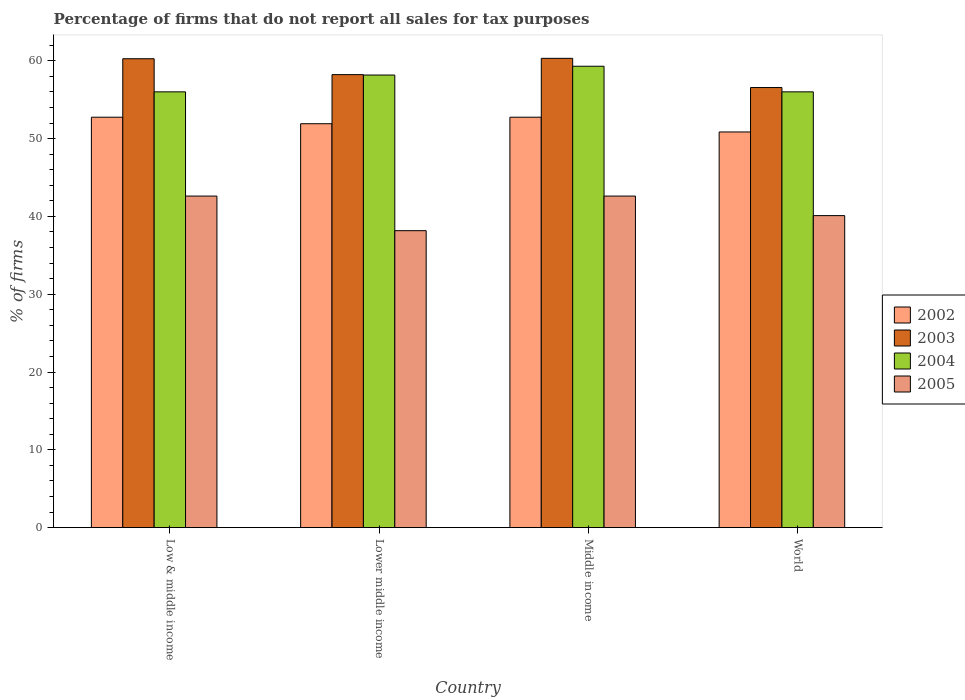How many different coloured bars are there?
Your response must be concise. 4. Are the number of bars per tick equal to the number of legend labels?
Provide a succinct answer. Yes. How many bars are there on the 4th tick from the left?
Your answer should be compact. 4. How many bars are there on the 4th tick from the right?
Offer a terse response. 4. What is the percentage of firms that do not report all sales for tax purposes in 2002 in Lower middle income?
Give a very brief answer. 51.91. Across all countries, what is the maximum percentage of firms that do not report all sales for tax purposes in 2004?
Keep it short and to the point. 59.3. Across all countries, what is the minimum percentage of firms that do not report all sales for tax purposes in 2002?
Offer a very short reply. 50.85. In which country was the percentage of firms that do not report all sales for tax purposes in 2004 maximum?
Your answer should be very brief. Middle income. What is the total percentage of firms that do not report all sales for tax purposes in 2004 in the graph?
Make the answer very short. 229.47. What is the difference between the percentage of firms that do not report all sales for tax purposes in 2002 in Lower middle income and that in Middle income?
Your answer should be very brief. -0.84. What is the difference between the percentage of firms that do not report all sales for tax purposes in 2004 in Middle income and the percentage of firms that do not report all sales for tax purposes in 2002 in World?
Provide a short and direct response. 8.45. What is the average percentage of firms that do not report all sales for tax purposes in 2005 per country?
Make the answer very short. 40.87. What is the difference between the percentage of firms that do not report all sales for tax purposes of/in 2003 and percentage of firms that do not report all sales for tax purposes of/in 2002 in World?
Ensure brevity in your answer.  5.71. In how many countries, is the percentage of firms that do not report all sales for tax purposes in 2005 greater than 50 %?
Offer a very short reply. 0. What is the ratio of the percentage of firms that do not report all sales for tax purposes in 2005 in Lower middle income to that in World?
Your answer should be compact. 0.95. What is the difference between the highest and the second highest percentage of firms that do not report all sales for tax purposes in 2002?
Offer a terse response. -0.84. What is the difference between the highest and the lowest percentage of firms that do not report all sales for tax purposes in 2005?
Ensure brevity in your answer.  4.45. In how many countries, is the percentage of firms that do not report all sales for tax purposes in 2003 greater than the average percentage of firms that do not report all sales for tax purposes in 2003 taken over all countries?
Give a very brief answer. 2. Is the sum of the percentage of firms that do not report all sales for tax purposes in 2002 in Lower middle income and Middle income greater than the maximum percentage of firms that do not report all sales for tax purposes in 2005 across all countries?
Keep it short and to the point. Yes. Is it the case that in every country, the sum of the percentage of firms that do not report all sales for tax purposes in 2003 and percentage of firms that do not report all sales for tax purposes in 2005 is greater than the sum of percentage of firms that do not report all sales for tax purposes in 2002 and percentage of firms that do not report all sales for tax purposes in 2004?
Offer a terse response. No. What does the 1st bar from the left in World represents?
Offer a terse response. 2002. How many bars are there?
Ensure brevity in your answer.  16. Are all the bars in the graph horizontal?
Offer a very short reply. No. How many countries are there in the graph?
Offer a very short reply. 4. Does the graph contain any zero values?
Offer a very short reply. No. Where does the legend appear in the graph?
Give a very brief answer. Center right. How are the legend labels stacked?
Your answer should be very brief. Vertical. What is the title of the graph?
Your answer should be compact. Percentage of firms that do not report all sales for tax purposes. Does "2006" appear as one of the legend labels in the graph?
Offer a terse response. No. What is the label or title of the X-axis?
Ensure brevity in your answer.  Country. What is the label or title of the Y-axis?
Your response must be concise. % of firms. What is the % of firms in 2002 in Low & middle income?
Provide a succinct answer. 52.75. What is the % of firms in 2003 in Low & middle income?
Ensure brevity in your answer.  60.26. What is the % of firms in 2004 in Low & middle income?
Give a very brief answer. 56.01. What is the % of firms of 2005 in Low & middle income?
Keep it short and to the point. 42.61. What is the % of firms of 2002 in Lower middle income?
Provide a succinct answer. 51.91. What is the % of firms of 2003 in Lower middle income?
Provide a short and direct response. 58.22. What is the % of firms in 2004 in Lower middle income?
Ensure brevity in your answer.  58.16. What is the % of firms of 2005 in Lower middle income?
Make the answer very short. 38.16. What is the % of firms in 2002 in Middle income?
Ensure brevity in your answer.  52.75. What is the % of firms in 2003 in Middle income?
Your answer should be very brief. 60.31. What is the % of firms of 2004 in Middle income?
Your answer should be compact. 59.3. What is the % of firms of 2005 in Middle income?
Your response must be concise. 42.61. What is the % of firms in 2002 in World?
Give a very brief answer. 50.85. What is the % of firms in 2003 in World?
Give a very brief answer. 56.56. What is the % of firms of 2004 in World?
Keep it short and to the point. 56.01. What is the % of firms of 2005 in World?
Give a very brief answer. 40.1. Across all countries, what is the maximum % of firms in 2002?
Provide a short and direct response. 52.75. Across all countries, what is the maximum % of firms of 2003?
Your response must be concise. 60.31. Across all countries, what is the maximum % of firms of 2004?
Offer a terse response. 59.3. Across all countries, what is the maximum % of firms of 2005?
Your answer should be very brief. 42.61. Across all countries, what is the minimum % of firms in 2002?
Offer a terse response. 50.85. Across all countries, what is the minimum % of firms in 2003?
Keep it short and to the point. 56.56. Across all countries, what is the minimum % of firms in 2004?
Give a very brief answer. 56.01. Across all countries, what is the minimum % of firms of 2005?
Provide a succinct answer. 38.16. What is the total % of firms in 2002 in the graph?
Make the answer very short. 208.25. What is the total % of firms of 2003 in the graph?
Offer a terse response. 235.35. What is the total % of firms of 2004 in the graph?
Give a very brief answer. 229.47. What is the total % of firms of 2005 in the graph?
Provide a succinct answer. 163.48. What is the difference between the % of firms of 2002 in Low & middle income and that in Lower middle income?
Provide a succinct answer. 0.84. What is the difference between the % of firms in 2003 in Low & middle income and that in Lower middle income?
Offer a very short reply. 2.04. What is the difference between the % of firms in 2004 in Low & middle income and that in Lower middle income?
Your response must be concise. -2.16. What is the difference between the % of firms in 2005 in Low & middle income and that in Lower middle income?
Keep it short and to the point. 4.45. What is the difference between the % of firms of 2002 in Low & middle income and that in Middle income?
Your response must be concise. 0. What is the difference between the % of firms of 2003 in Low & middle income and that in Middle income?
Your response must be concise. -0.05. What is the difference between the % of firms of 2004 in Low & middle income and that in Middle income?
Keep it short and to the point. -3.29. What is the difference between the % of firms of 2005 in Low & middle income and that in Middle income?
Give a very brief answer. 0. What is the difference between the % of firms in 2002 in Low & middle income and that in World?
Offer a very short reply. 1.89. What is the difference between the % of firms of 2005 in Low & middle income and that in World?
Keep it short and to the point. 2.51. What is the difference between the % of firms in 2002 in Lower middle income and that in Middle income?
Give a very brief answer. -0.84. What is the difference between the % of firms of 2003 in Lower middle income and that in Middle income?
Offer a terse response. -2.09. What is the difference between the % of firms of 2004 in Lower middle income and that in Middle income?
Offer a terse response. -1.13. What is the difference between the % of firms of 2005 in Lower middle income and that in Middle income?
Your answer should be compact. -4.45. What is the difference between the % of firms in 2002 in Lower middle income and that in World?
Ensure brevity in your answer.  1.06. What is the difference between the % of firms of 2003 in Lower middle income and that in World?
Provide a short and direct response. 1.66. What is the difference between the % of firms in 2004 in Lower middle income and that in World?
Provide a succinct answer. 2.16. What is the difference between the % of firms in 2005 in Lower middle income and that in World?
Your answer should be compact. -1.94. What is the difference between the % of firms of 2002 in Middle income and that in World?
Offer a very short reply. 1.89. What is the difference between the % of firms of 2003 in Middle income and that in World?
Your answer should be compact. 3.75. What is the difference between the % of firms of 2004 in Middle income and that in World?
Offer a terse response. 3.29. What is the difference between the % of firms of 2005 in Middle income and that in World?
Offer a very short reply. 2.51. What is the difference between the % of firms of 2002 in Low & middle income and the % of firms of 2003 in Lower middle income?
Keep it short and to the point. -5.47. What is the difference between the % of firms in 2002 in Low & middle income and the % of firms in 2004 in Lower middle income?
Keep it short and to the point. -5.42. What is the difference between the % of firms in 2002 in Low & middle income and the % of firms in 2005 in Lower middle income?
Your answer should be very brief. 14.58. What is the difference between the % of firms in 2003 in Low & middle income and the % of firms in 2004 in Lower middle income?
Your answer should be very brief. 2.1. What is the difference between the % of firms of 2003 in Low & middle income and the % of firms of 2005 in Lower middle income?
Make the answer very short. 22.1. What is the difference between the % of firms in 2004 in Low & middle income and the % of firms in 2005 in Lower middle income?
Your answer should be compact. 17.84. What is the difference between the % of firms in 2002 in Low & middle income and the % of firms in 2003 in Middle income?
Make the answer very short. -7.57. What is the difference between the % of firms of 2002 in Low & middle income and the % of firms of 2004 in Middle income?
Ensure brevity in your answer.  -6.55. What is the difference between the % of firms of 2002 in Low & middle income and the % of firms of 2005 in Middle income?
Offer a terse response. 10.13. What is the difference between the % of firms in 2003 in Low & middle income and the % of firms in 2005 in Middle income?
Offer a very short reply. 17.65. What is the difference between the % of firms of 2004 in Low & middle income and the % of firms of 2005 in Middle income?
Your answer should be compact. 13.39. What is the difference between the % of firms in 2002 in Low & middle income and the % of firms in 2003 in World?
Your response must be concise. -3.81. What is the difference between the % of firms of 2002 in Low & middle income and the % of firms of 2004 in World?
Keep it short and to the point. -3.26. What is the difference between the % of firms of 2002 in Low & middle income and the % of firms of 2005 in World?
Offer a very short reply. 12.65. What is the difference between the % of firms of 2003 in Low & middle income and the % of firms of 2004 in World?
Make the answer very short. 4.25. What is the difference between the % of firms of 2003 in Low & middle income and the % of firms of 2005 in World?
Your answer should be very brief. 20.16. What is the difference between the % of firms of 2004 in Low & middle income and the % of firms of 2005 in World?
Offer a very short reply. 15.91. What is the difference between the % of firms of 2002 in Lower middle income and the % of firms of 2003 in Middle income?
Offer a very short reply. -8.4. What is the difference between the % of firms in 2002 in Lower middle income and the % of firms in 2004 in Middle income?
Give a very brief answer. -7.39. What is the difference between the % of firms in 2002 in Lower middle income and the % of firms in 2005 in Middle income?
Your answer should be very brief. 9.3. What is the difference between the % of firms of 2003 in Lower middle income and the % of firms of 2004 in Middle income?
Your answer should be very brief. -1.08. What is the difference between the % of firms in 2003 in Lower middle income and the % of firms in 2005 in Middle income?
Give a very brief answer. 15.61. What is the difference between the % of firms in 2004 in Lower middle income and the % of firms in 2005 in Middle income?
Make the answer very short. 15.55. What is the difference between the % of firms of 2002 in Lower middle income and the % of firms of 2003 in World?
Your answer should be very brief. -4.65. What is the difference between the % of firms in 2002 in Lower middle income and the % of firms in 2004 in World?
Offer a very short reply. -4.1. What is the difference between the % of firms of 2002 in Lower middle income and the % of firms of 2005 in World?
Provide a short and direct response. 11.81. What is the difference between the % of firms in 2003 in Lower middle income and the % of firms in 2004 in World?
Offer a terse response. 2.21. What is the difference between the % of firms in 2003 in Lower middle income and the % of firms in 2005 in World?
Your response must be concise. 18.12. What is the difference between the % of firms of 2004 in Lower middle income and the % of firms of 2005 in World?
Provide a succinct answer. 18.07. What is the difference between the % of firms in 2002 in Middle income and the % of firms in 2003 in World?
Your answer should be compact. -3.81. What is the difference between the % of firms of 2002 in Middle income and the % of firms of 2004 in World?
Your response must be concise. -3.26. What is the difference between the % of firms of 2002 in Middle income and the % of firms of 2005 in World?
Offer a very short reply. 12.65. What is the difference between the % of firms in 2003 in Middle income and the % of firms in 2004 in World?
Your response must be concise. 4.31. What is the difference between the % of firms of 2003 in Middle income and the % of firms of 2005 in World?
Provide a succinct answer. 20.21. What is the difference between the % of firms of 2004 in Middle income and the % of firms of 2005 in World?
Your answer should be very brief. 19.2. What is the average % of firms of 2002 per country?
Give a very brief answer. 52.06. What is the average % of firms in 2003 per country?
Make the answer very short. 58.84. What is the average % of firms of 2004 per country?
Offer a terse response. 57.37. What is the average % of firms in 2005 per country?
Offer a very short reply. 40.87. What is the difference between the % of firms in 2002 and % of firms in 2003 in Low & middle income?
Your response must be concise. -7.51. What is the difference between the % of firms of 2002 and % of firms of 2004 in Low & middle income?
Keep it short and to the point. -3.26. What is the difference between the % of firms in 2002 and % of firms in 2005 in Low & middle income?
Your response must be concise. 10.13. What is the difference between the % of firms of 2003 and % of firms of 2004 in Low & middle income?
Offer a terse response. 4.25. What is the difference between the % of firms of 2003 and % of firms of 2005 in Low & middle income?
Offer a terse response. 17.65. What is the difference between the % of firms of 2004 and % of firms of 2005 in Low & middle income?
Offer a terse response. 13.39. What is the difference between the % of firms of 2002 and % of firms of 2003 in Lower middle income?
Provide a short and direct response. -6.31. What is the difference between the % of firms of 2002 and % of firms of 2004 in Lower middle income?
Provide a succinct answer. -6.26. What is the difference between the % of firms in 2002 and % of firms in 2005 in Lower middle income?
Make the answer very short. 13.75. What is the difference between the % of firms of 2003 and % of firms of 2004 in Lower middle income?
Provide a succinct answer. 0.05. What is the difference between the % of firms in 2003 and % of firms in 2005 in Lower middle income?
Provide a succinct answer. 20.06. What is the difference between the % of firms in 2004 and % of firms in 2005 in Lower middle income?
Offer a very short reply. 20. What is the difference between the % of firms of 2002 and % of firms of 2003 in Middle income?
Your answer should be compact. -7.57. What is the difference between the % of firms in 2002 and % of firms in 2004 in Middle income?
Offer a very short reply. -6.55. What is the difference between the % of firms of 2002 and % of firms of 2005 in Middle income?
Ensure brevity in your answer.  10.13. What is the difference between the % of firms of 2003 and % of firms of 2004 in Middle income?
Offer a terse response. 1.02. What is the difference between the % of firms of 2003 and % of firms of 2005 in Middle income?
Ensure brevity in your answer.  17.7. What is the difference between the % of firms in 2004 and % of firms in 2005 in Middle income?
Provide a short and direct response. 16.69. What is the difference between the % of firms in 2002 and % of firms in 2003 in World?
Your answer should be compact. -5.71. What is the difference between the % of firms in 2002 and % of firms in 2004 in World?
Your response must be concise. -5.15. What is the difference between the % of firms in 2002 and % of firms in 2005 in World?
Your answer should be compact. 10.75. What is the difference between the % of firms in 2003 and % of firms in 2004 in World?
Provide a succinct answer. 0.56. What is the difference between the % of firms of 2003 and % of firms of 2005 in World?
Offer a very short reply. 16.46. What is the difference between the % of firms in 2004 and % of firms in 2005 in World?
Provide a succinct answer. 15.91. What is the ratio of the % of firms in 2002 in Low & middle income to that in Lower middle income?
Your response must be concise. 1.02. What is the ratio of the % of firms of 2003 in Low & middle income to that in Lower middle income?
Your response must be concise. 1.04. What is the ratio of the % of firms in 2004 in Low & middle income to that in Lower middle income?
Offer a very short reply. 0.96. What is the ratio of the % of firms of 2005 in Low & middle income to that in Lower middle income?
Keep it short and to the point. 1.12. What is the ratio of the % of firms of 2002 in Low & middle income to that in Middle income?
Provide a short and direct response. 1. What is the ratio of the % of firms of 2004 in Low & middle income to that in Middle income?
Make the answer very short. 0.94. What is the ratio of the % of firms in 2002 in Low & middle income to that in World?
Offer a terse response. 1.04. What is the ratio of the % of firms in 2003 in Low & middle income to that in World?
Your answer should be very brief. 1.07. What is the ratio of the % of firms of 2004 in Low & middle income to that in World?
Provide a short and direct response. 1. What is the ratio of the % of firms in 2005 in Low & middle income to that in World?
Offer a very short reply. 1.06. What is the ratio of the % of firms in 2002 in Lower middle income to that in Middle income?
Offer a terse response. 0.98. What is the ratio of the % of firms of 2003 in Lower middle income to that in Middle income?
Your answer should be very brief. 0.97. What is the ratio of the % of firms in 2004 in Lower middle income to that in Middle income?
Offer a very short reply. 0.98. What is the ratio of the % of firms of 2005 in Lower middle income to that in Middle income?
Provide a succinct answer. 0.9. What is the ratio of the % of firms of 2002 in Lower middle income to that in World?
Give a very brief answer. 1.02. What is the ratio of the % of firms of 2003 in Lower middle income to that in World?
Keep it short and to the point. 1.03. What is the ratio of the % of firms of 2004 in Lower middle income to that in World?
Give a very brief answer. 1.04. What is the ratio of the % of firms in 2005 in Lower middle income to that in World?
Keep it short and to the point. 0.95. What is the ratio of the % of firms of 2002 in Middle income to that in World?
Provide a short and direct response. 1.04. What is the ratio of the % of firms of 2003 in Middle income to that in World?
Give a very brief answer. 1.07. What is the ratio of the % of firms in 2004 in Middle income to that in World?
Offer a terse response. 1.06. What is the ratio of the % of firms of 2005 in Middle income to that in World?
Your response must be concise. 1.06. What is the difference between the highest and the second highest % of firms of 2002?
Provide a succinct answer. 0. What is the difference between the highest and the second highest % of firms of 2003?
Your answer should be very brief. 0.05. What is the difference between the highest and the second highest % of firms of 2004?
Provide a short and direct response. 1.13. What is the difference between the highest and the second highest % of firms of 2005?
Ensure brevity in your answer.  0. What is the difference between the highest and the lowest % of firms in 2002?
Offer a terse response. 1.89. What is the difference between the highest and the lowest % of firms of 2003?
Your response must be concise. 3.75. What is the difference between the highest and the lowest % of firms of 2004?
Ensure brevity in your answer.  3.29. What is the difference between the highest and the lowest % of firms in 2005?
Your answer should be compact. 4.45. 